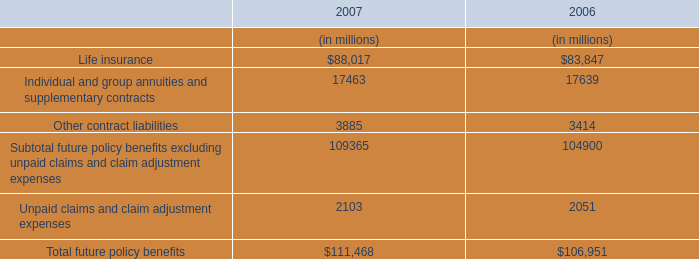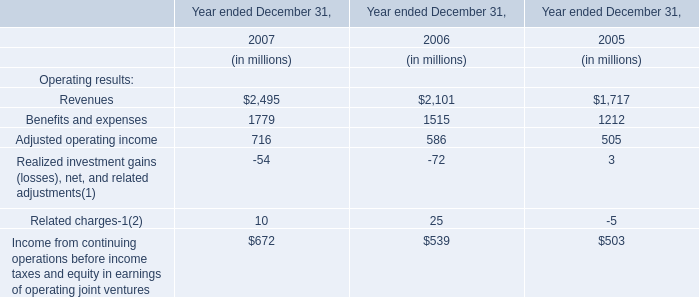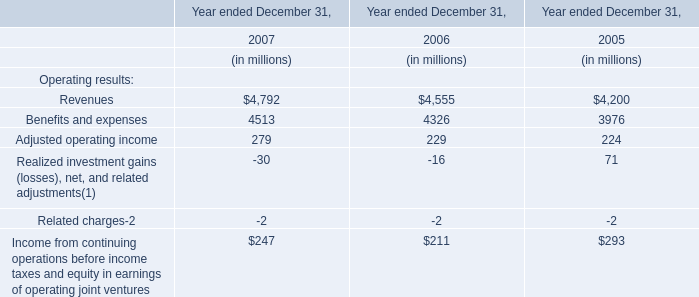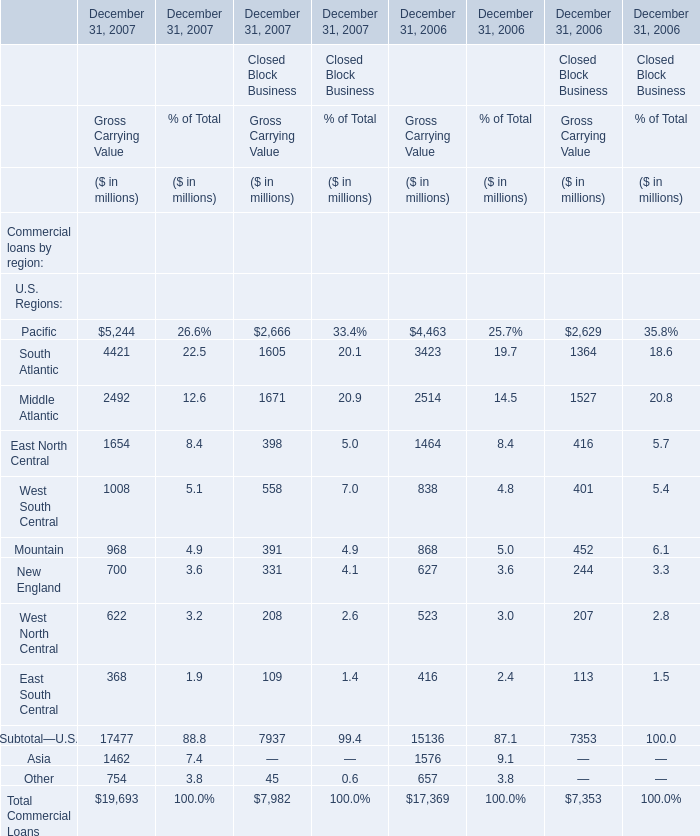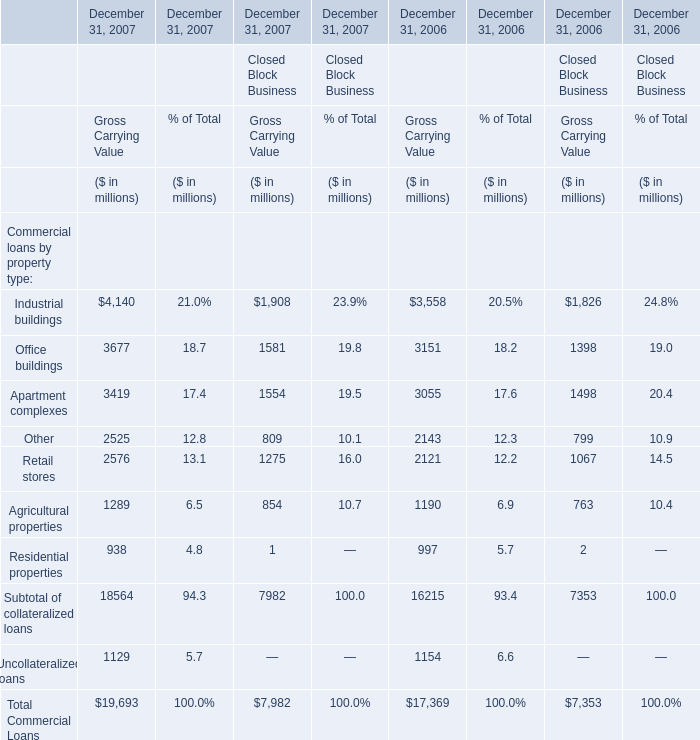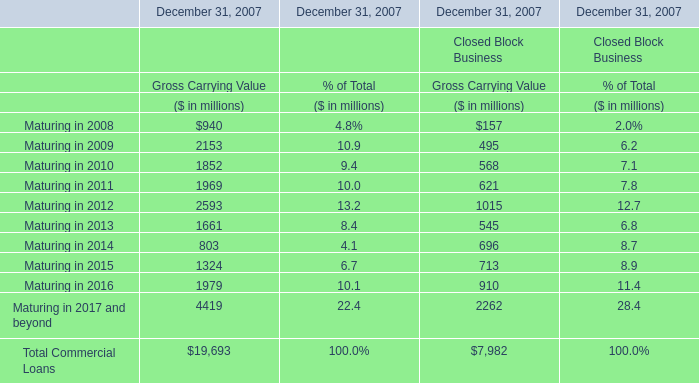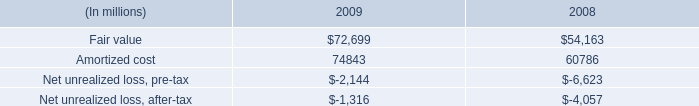In the section with largest amount of Industrial buildings , what's the sum of Apartment complexes for Gross Carrying Value? (in million) 
Computations: (((3419 + 1554) + 3055) + 1498)
Answer: 9526.0. 